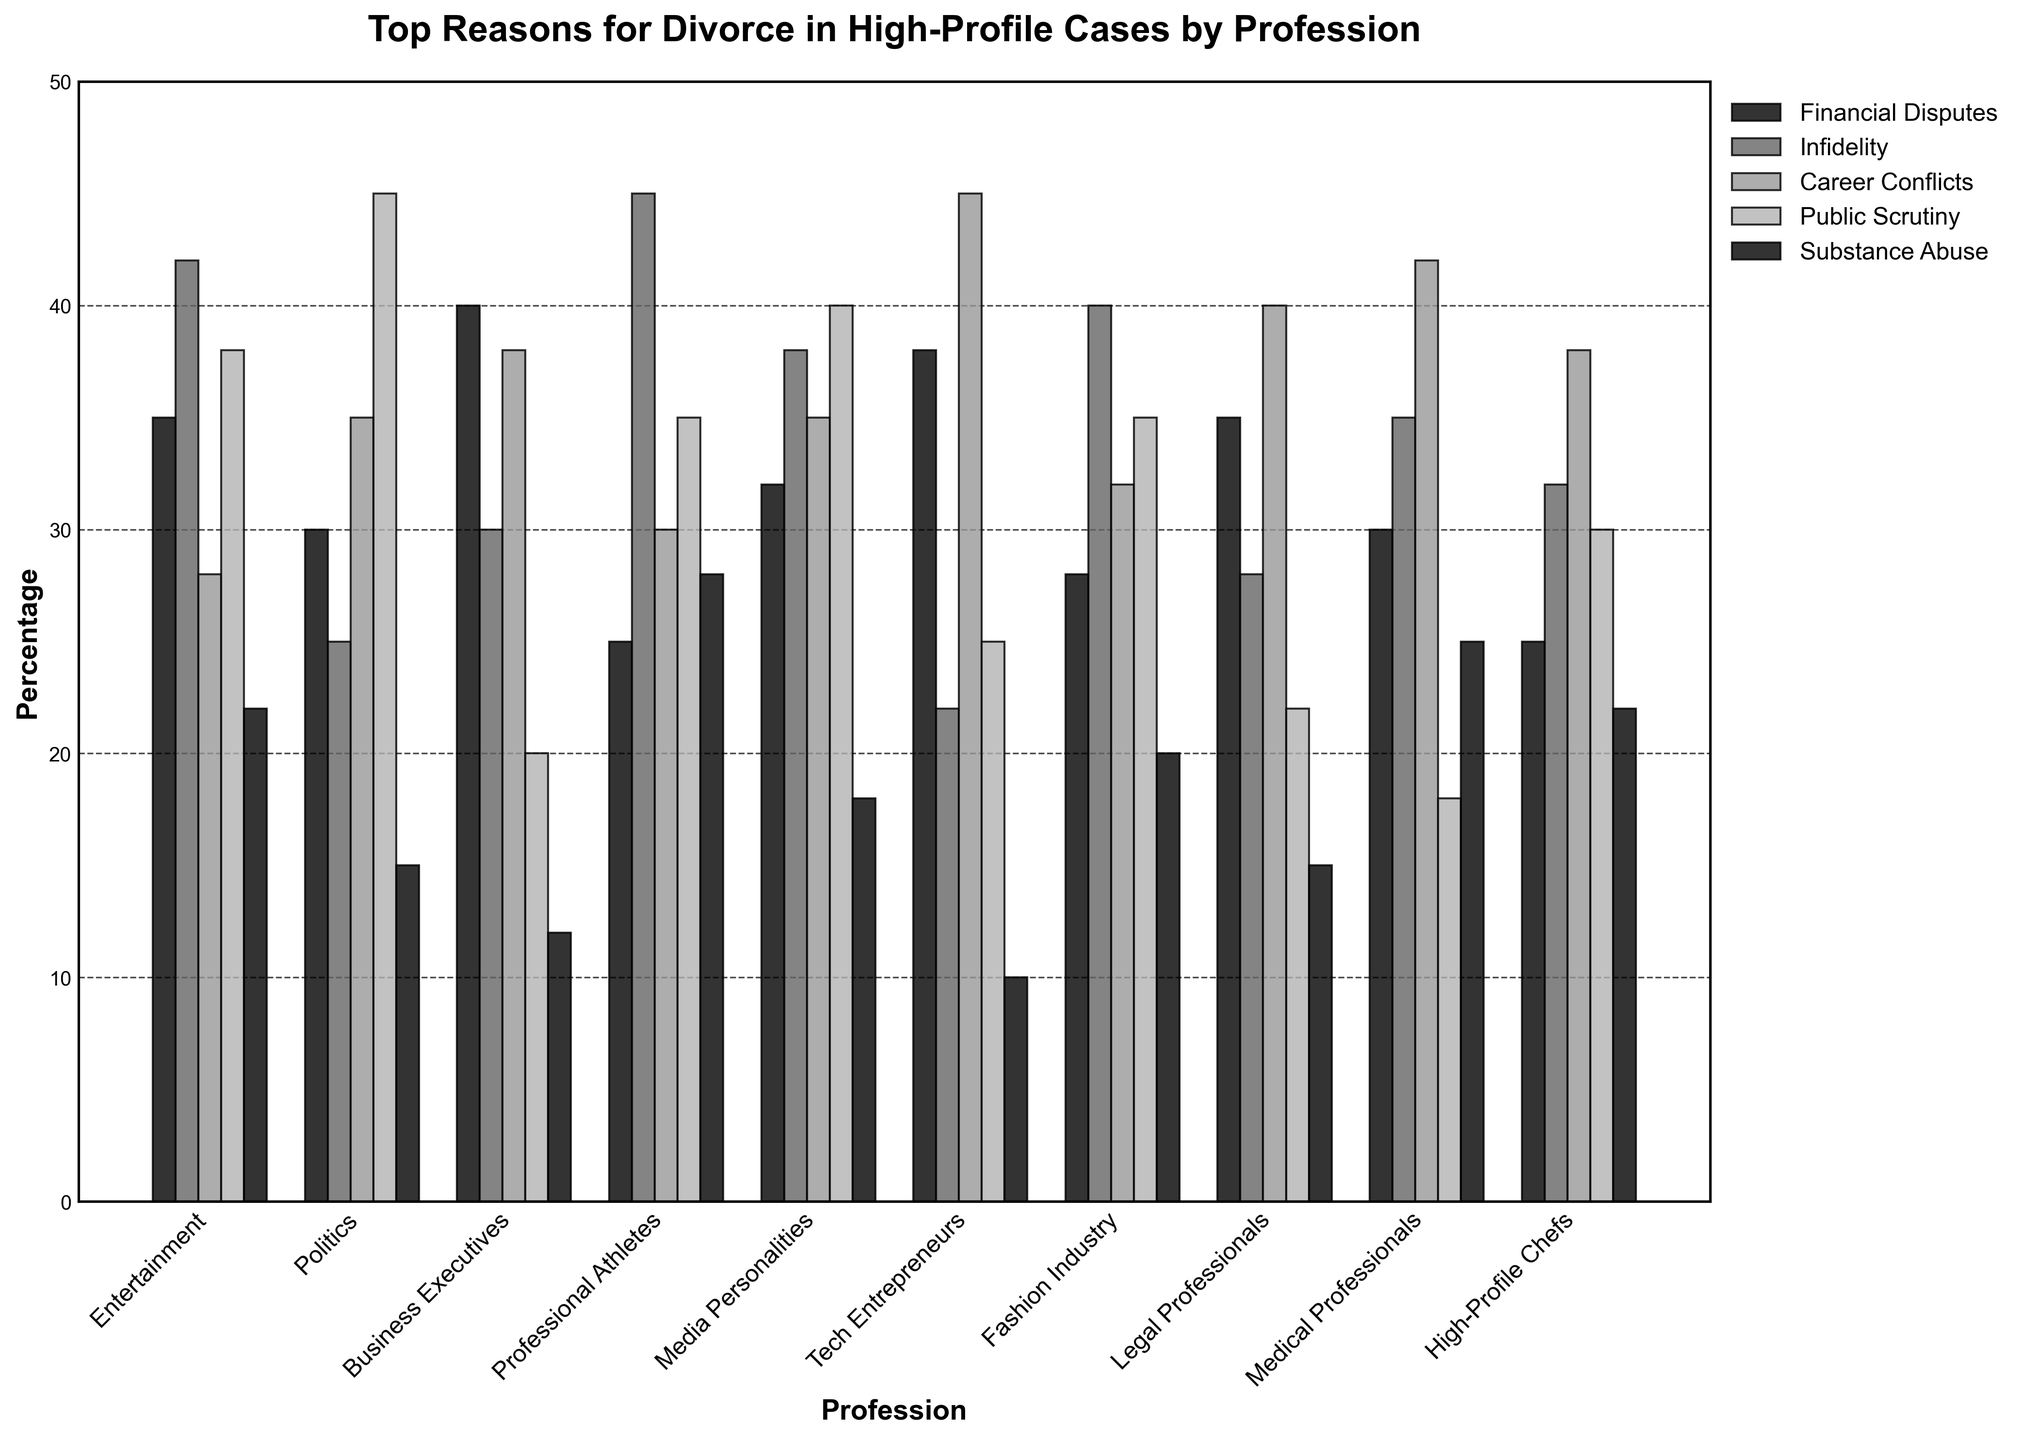Which profession has the highest percentage of divorces due to infidelity? By comparing the heights of the bars representing 'Infidelity' across all professions, the highest bar is for Professional Athletes at 45%.
Answer: Professional Athletes Which profession has the lowest percentage of divorces due to substance abuse? Observing the bars for 'Substance Abuse', Tech Entrepreneurs have the lowest bar at 10%.
Answer: Tech Entrepreneurs How does the percentage of divorces due to career conflicts in the Tech Entrepreneurs category compare to those in the Medical Professionals category? The bar for 'Career Conflicts' is higher for Tech Entrepreneurs at 45% compared to 42% for Medical Professionals.
Answer: Higher What is the sum of the percentages for financial disputes and career conflicts in Politics? The percentage for 'Financial Disputes' is 30% and for 'Career Conflicts' is 35%. Summing these values, 30 + 35 = 65%.
Answer: 65% Which two professions have the same percentage of divorces due to financial disputes? Observing the heights of the bars for 'Financial Disputes', both Entertainment and Legal Professionals have bars at 35%.
Answer: Entertainment and Legal Professionals What is the difference in the percentage of divorces due to public scrutiny between Entertainment professionals and Media Personalities? The percentage for 'Public Scrutiny' in Entertainment is 38% and in Media Personalities is 40%. The difference is 40 - 38 = 2%.
Answer: 2% Which profession has the highest percentage of divorces due to public scrutiny? By looking at the bars for 'Public Scrutiny', Politics has the highest value at 45%.
Answer: Politics What is the average percentage of divorces due to infidelity across all professions? Summing the percentages for 'Infidelity' across all professions (42+25+30+45+38+22+40+28+35+32) and dividing by 10, (42+25+30+45+38+22+40+28+35+32)/10 = 337/10 = 33.7%.
Answer: 33.7% Which profession shows the greatest disparity between the highest and lowest reasons for divorce? For each profession, find the range by subtracting the lowest percentage from the highest. Politics shows the greatest disparity with 45% (Public Scrutiny) - 15% (Substance Abuse) = 30%.
Answer: Politics 